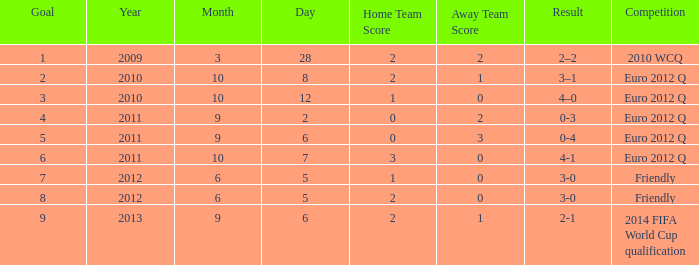How many goals when the score is 3-0 in the euro 2012 q? 1.0. 